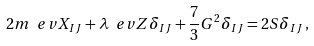<formula> <loc_0><loc_0><loc_500><loc_500>2 m \ e v { X _ { I J } } + \lambda \ e v { Z } \delta _ { I J } + \frac { 7 } { 3 } G ^ { 2 } \delta _ { I J } = 2 S \delta _ { I J } \, ,</formula> 